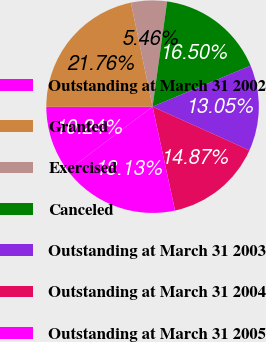<chart> <loc_0><loc_0><loc_500><loc_500><pie_chart><fcel>Outstanding at March 31 2002<fcel>Granted<fcel>Exercised<fcel>Canceled<fcel>Outstanding at March 31 2003<fcel>Outstanding at March 31 2004<fcel>Outstanding at March 31 2005<nl><fcel>10.24%<fcel>21.76%<fcel>5.46%<fcel>16.5%<fcel>13.05%<fcel>14.87%<fcel>18.13%<nl></chart> 